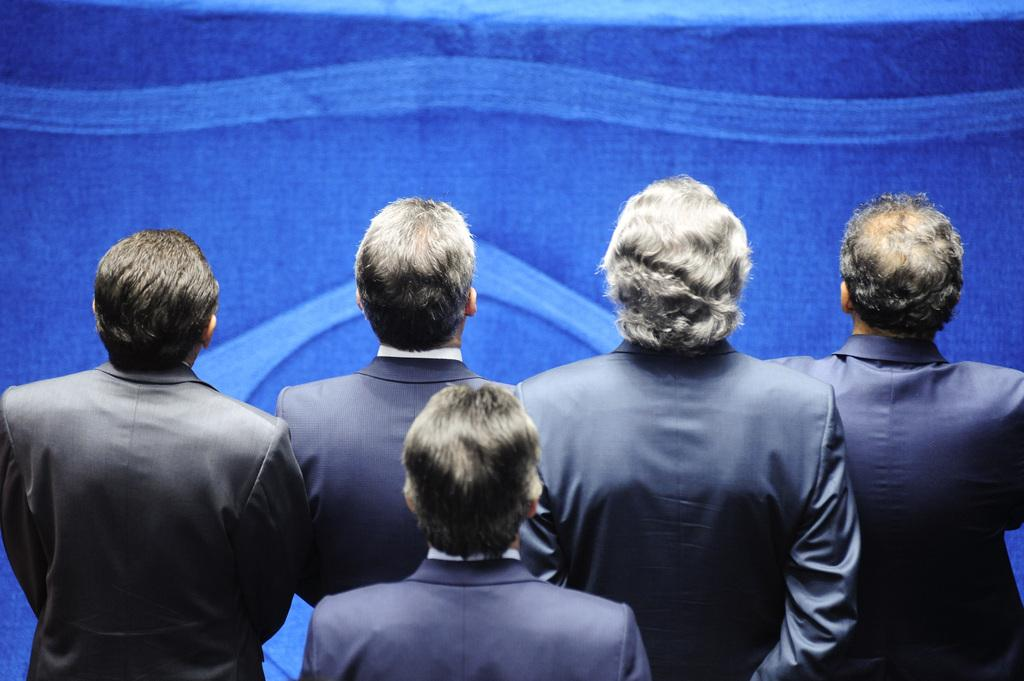What can be seen at the bottom of the image? There is a group of people standing at the bottom of the image. What is visible in the background of the image? There is a wall in the background of the image. Where is the hose located in the image? There is no hose present in the image. What type of division can be seen between the group of people and the wall in the image? There is no specific division visible between the group of people and the wall in the image. Can you see a car in the image? There is no car present in the image. 